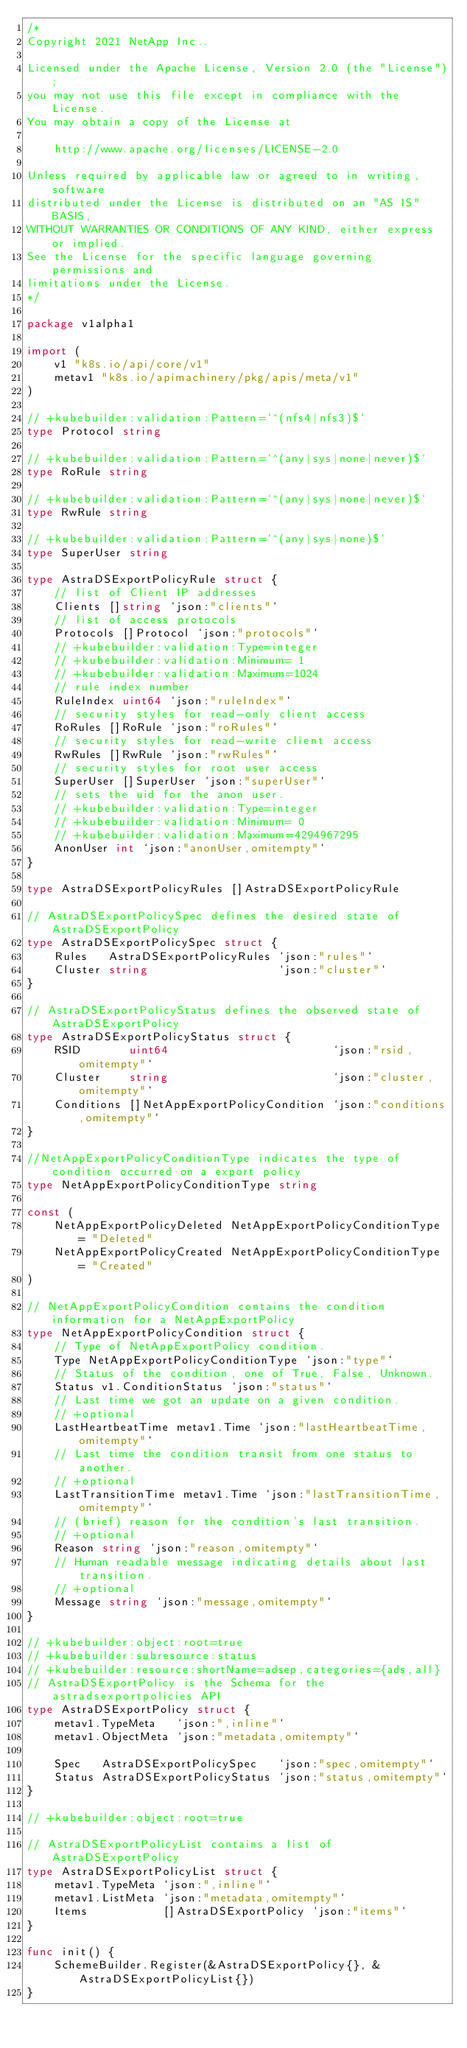<code> <loc_0><loc_0><loc_500><loc_500><_Go_>/*
Copyright 2021 NetApp Inc..

Licensed under the Apache License, Version 2.0 (the "License");
you may not use this file except in compliance with the License.
You may obtain a copy of the License at

    http://www.apache.org/licenses/LICENSE-2.0

Unless required by applicable law or agreed to in writing, software
distributed under the License is distributed on an "AS IS" BASIS,
WITHOUT WARRANTIES OR CONDITIONS OF ANY KIND, either express or implied.
See the License for the specific language governing permissions and
limitations under the License.
*/

package v1alpha1

import (
	v1 "k8s.io/api/core/v1"
	metav1 "k8s.io/apimachinery/pkg/apis/meta/v1"
)

// +kubebuilder:validation:Pattern=`^(nfs4|nfs3)$`
type Protocol string

// +kubebuilder:validation:Pattern=`^(any|sys|none|never)$`
type RoRule string

// +kubebuilder:validation:Pattern=`^(any|sys|none|never)$`
type RwRule string

// +kubebuilder:validation:Pattern=`^(any|sys|none)$`
type SuperUser string

type AstraDSExportPolicyRule struct {
	// list of Client IP addresses
	Clients []string `json:"clients"`
	// list of access protocols
	Protocols []Protocol `json:"protocols"`
	// +kubebuilder:validation:Type=integer
	// +kubebuilder:validation:Minimum= 1
	// +kubebuilder:validation:Maximum=1024
	// rule index number
	RuleIndex uint64 `json:"ruleIndex"`
	// security styles for read-only client access
	RoRules []RoRule `json:"roRules"`
	// security styles for read-write client access
	RwRules []RwRule `json:"rwRules"`
	// security styles for root user access
	SuperUser []SuperUser `json:"superUser"`
	// sets the uid for the anon user.
	// +kubebuilder:validation:Type=integer
	// +kubebuilder:validation:Minimum= 0
	// +kubebuilder:validation:Maximum=4294967295
	AnonUser int `json:"anonUser,omitempty"`
}

type AstraDSExportPolicyRules []AstraDSExportPolicyRule

// AstraDSExportPolicySpec defines the desired state of AstraDSExportPolicy
type AstraDSExportPolicySpec struct {
	Rules   AstraDSExportPolicyRules `json:"rules"`
	Cluster string                   `json:"cluster"`
}

// AstraDSExportPolicyStatus defines the observed state of AstraDSExportPolicy
type AstraDSExportPolicyStatus struct {
	RSID       uint64                        `json:"rsid,omitempty"`
	Cluster    string                        `json:"cluster,omitempty"`
	Conditions []NetAppExportPolicyCondition `json:"conditions,omitempty"`
}

//NetAppExportPolicyConditionType indicates the type of condition occurred on a export policy
type NetAppExportPolicyConditionType string

const (
	NetAppExportPolicyDeleted NetAppExportPolicyConditionType = "Deleted"
	NetAppExportPolicyCreated NetAppExportPolicyConditionType = "Created"
)

// NetAppExportPolicyCondition contains the condition information for a NetAppExportPolicy
type NetAppExportPolicyCondition struct {
	// Type of NetAppExportPolicy condition.
	Type NetAppExportPolicyConditionType `json:"type"`
	// Status of the condition, one of True, False, Unknown.
	Status v1.ConditionStatus `json:"status"`
	// Last time we got an update on a given condition.
	// +optional
	LastHeartbeatTime metav1.Time `json:"lastHeartbeatTime,omitempty"`
	// Last time the condition transit from one status to another.
	// +optional
	LastTransitionTime metav1.Time `json:"lastTransitionTime,omitempty"`
	// (brief) reason for the condition's last transition.
	// +optional
	Reason string `json:"reason,omitempty"`
	// Human readable message indicating details about last transition.
	// +optional
	Message string `json:"message,omitempty"`
}

// +kubebuilder:object:root=true
// +kubebuilder:subresource:status
// +kubebuilder:resource:shortName=adsep,categories={ads,all}
// AstraDSExportPolicy is the Schema for the astradsexportpolicies API
type AstraDSExportPolicy struct {
	metav1.TypeMeta   `json:",inline"`
	metav1.ObjectMeta `json:"metadata,omitempty"`

	Spec   AstraDSExportPolicySpec   `json:"spec,omitempty"`
	Status AstraDSExportPolicyStatus `json:"status,omitempty"`
}

// +kubebuilder:object:root=true

// AstraDSExportPolicyList contains a list of AstraDSExportPolicy
type AstraDSExportPolicyList struct {
	metav1.TypeMeta `json:",inline"`
	metav1.ListMeta `json:"metadata,omitempty"`
	Items           []AstraDSExportPolicy `json:"items"`
}

func init() {
	SchemeBuilder.Register(&AstraDSExportPolicy{}, &AstraDSExportPolicyList{})
}
</code> 